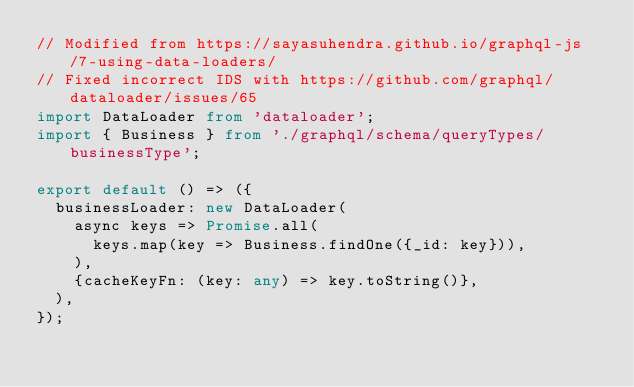Convert code to text. <code><loc_0><loc_0><loc_500><loc_500><_TypeScript_>// Modified from https://sayasuhendra.github.io/graphql-js/7-using-data-loaders/
// Fixed incorrect IDS with https://github.com/graphql/dataloader/issues/65
import DataLoader from 'dataloader';
import { Business } from './graphql/schema/queryTypes/businessType';

export default () => ({
  businessLoader: new DataLoader(
    async keys => Promise.all(
      keys.map(key => Business.findOne({_id: key})),
    ),
    {cacheKeyFn: (key: any) => key.toString()},
  ),
});
</code> 